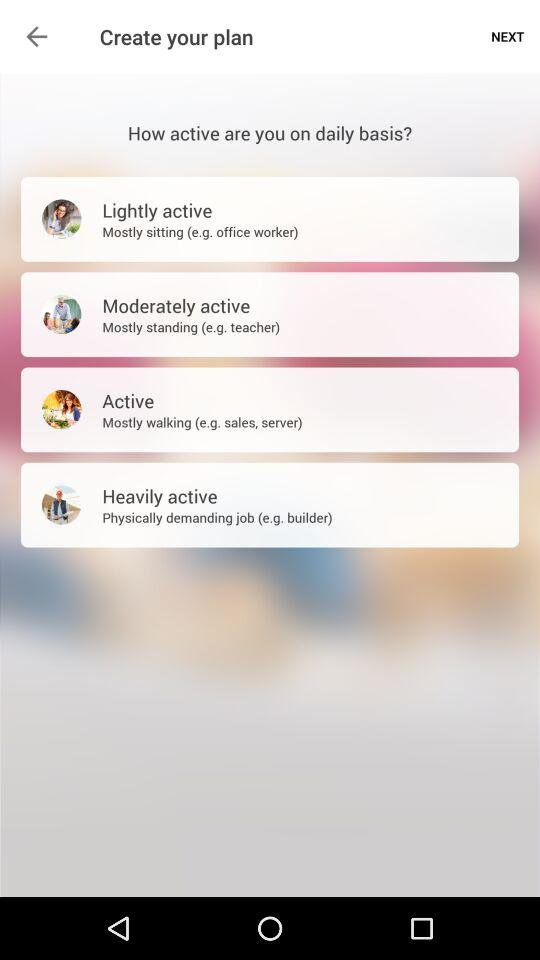Which example is given of "Lightly active"? The given example of "Lightly active" is an office worker. 